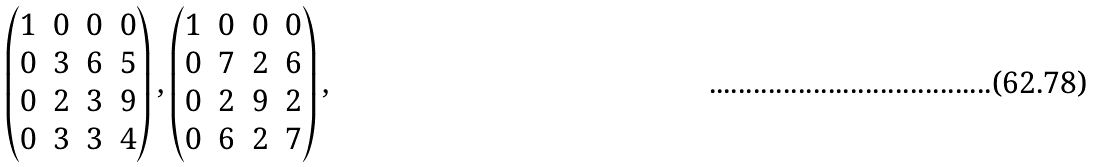Convert formula to latex. <formula><loc_0><loc_0><loc_500><loc_500>\begin{pmatrix} 1 & 0 & 0 & 0 \\ 0 & 3 & 6 & 5 \\ 0 & 2 & 3 & 9 \\ 0 & 3 & 3 & 4 \end{pmatrix} , \begin{pmatrix} 1 & 0 & 0 & 0 \\ 0 & 7 & 2 & 6 \\ 0 & 2 & 9 & 2 \\ 0 & 6 & 2 & 7 \end{pmatrix} ,</formula> 